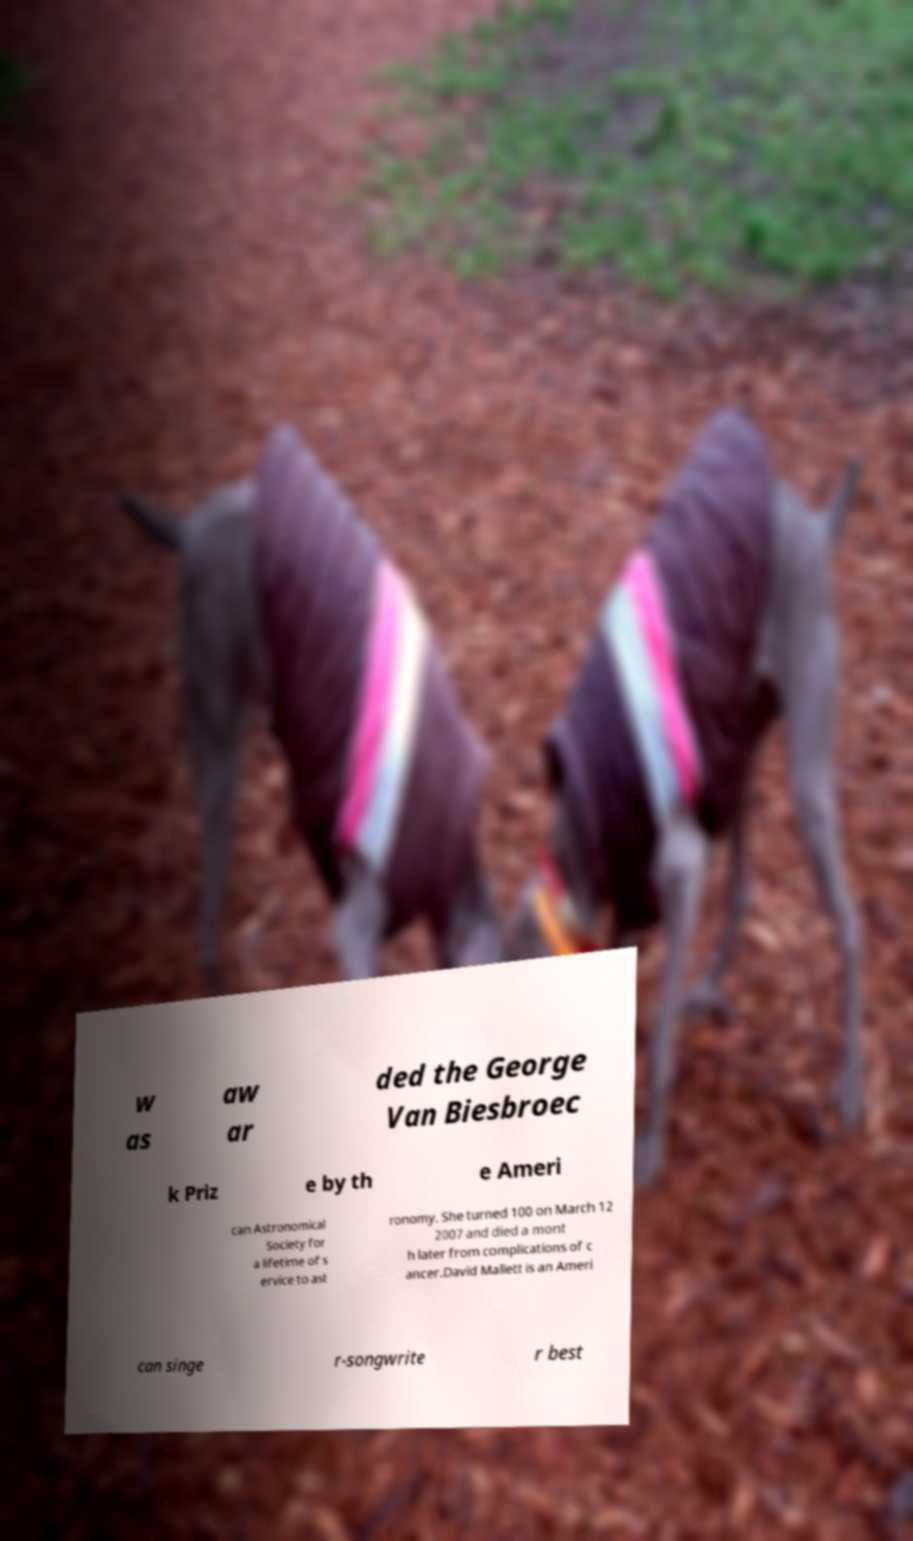I need the written content from this picture converted into text. Can you do that? w as aw ar ded the George Van Biesbroec k Priz e by th e Ameri can Astronomical Society for a lifetime of s ervice to ast ronomy. She turned 100 on March 12 2007 and died a mont h later from complications of c ancer.David Mallett is an Ameri can singe r-songwrite r best 